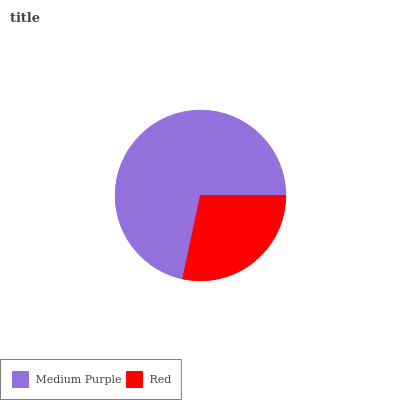Is Red the minimum?
Answer yes or no. Yes. Is Medium Purple the maximum?
Answer yes or no. Yes. Is Red the maximum?
Answer yes or no. No. Is Medium Purple greater than Red?
Answer yes or no. Yes. Is Red less than Medium Purple?
Answer yes or no. Yes. Is Red greater than Medium Purple?
Answer yes or no. No. Is Medium Purple less than Red?
Answer yes or no. No. Is Medium Purple the high median?
Answer yes or no. Yes. Is Red the low median?
Answer yes or no. Yes. Is Red the high median?
Answer yes or no. No. Is Medium Purple the low median?
Answer yes or no. No. 